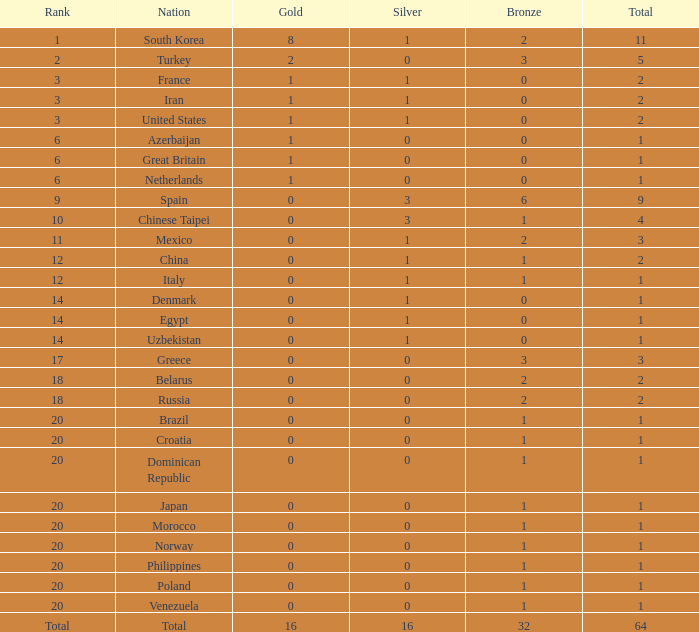What is the lowest number of gold medals the nation with less than 0 silver medals has? None. 